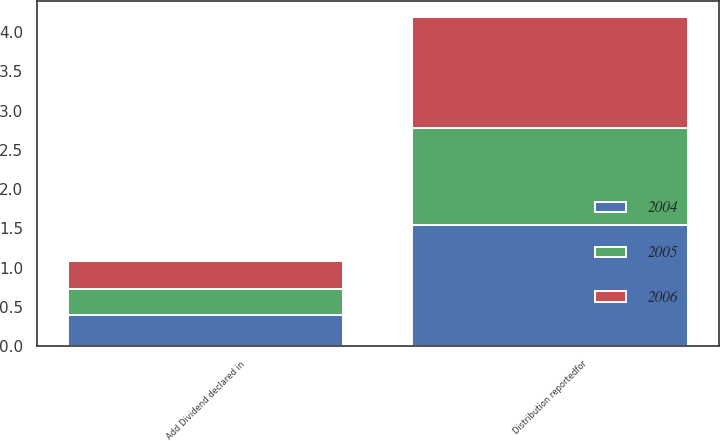Convert chart. <chart><loc_0><loc_0><loc_500><loc_500><stacked_bar_chart><ecel><fcel>Distribution reportedfor<fcel>Add Dividend declared in<nl><fcel>2004<fcel>1.54<fcel>0.4<nl><fcel>2006<fcel>1.41<fcel>0.36<nl><fcel>2005<fcel>1.24<fcel>0.33<nl></chart> 